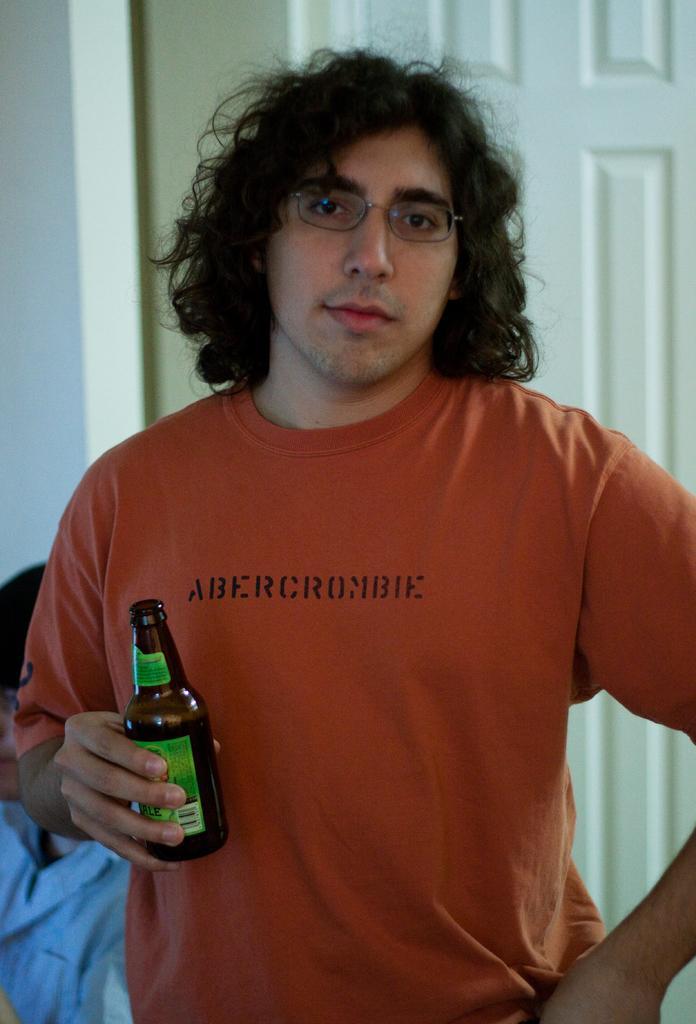In one or two sentences, can you explain what this image depicts? In this image there are two men. In the middle of the image a man is standing holding a bottle in his hand. At the background a man is sitting and there is a wall and a door. 